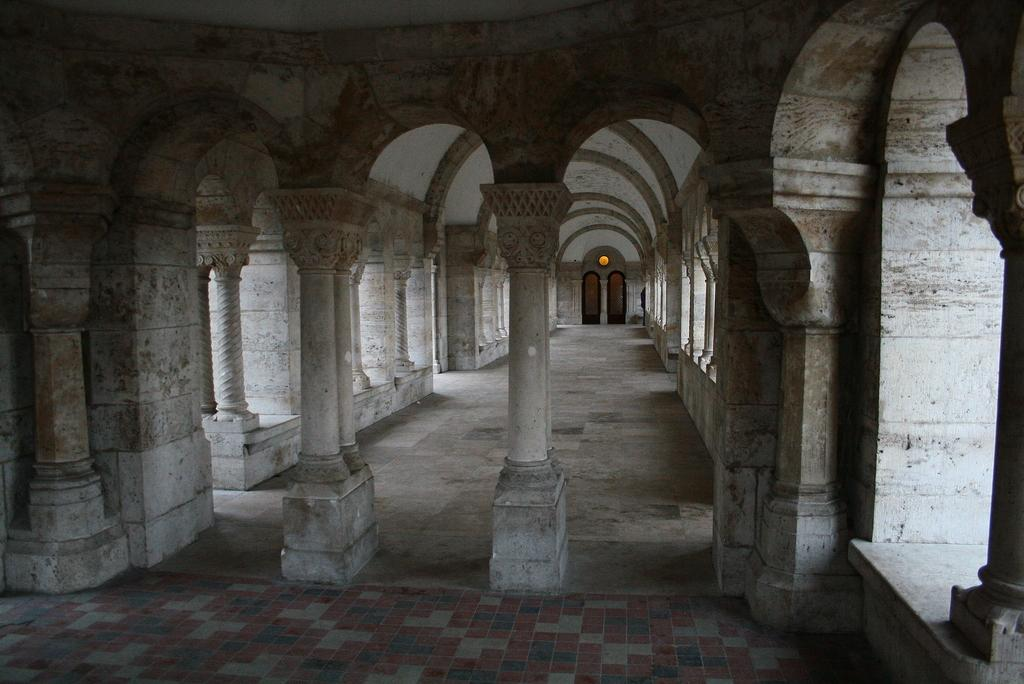What architectural features can be seen in the image? There are arches and pillars in the image. Can you describe the lighting in the image? There is a light attached to a wall in the image. How many chairs can be seen in the image? There are no chairs present in the image. 